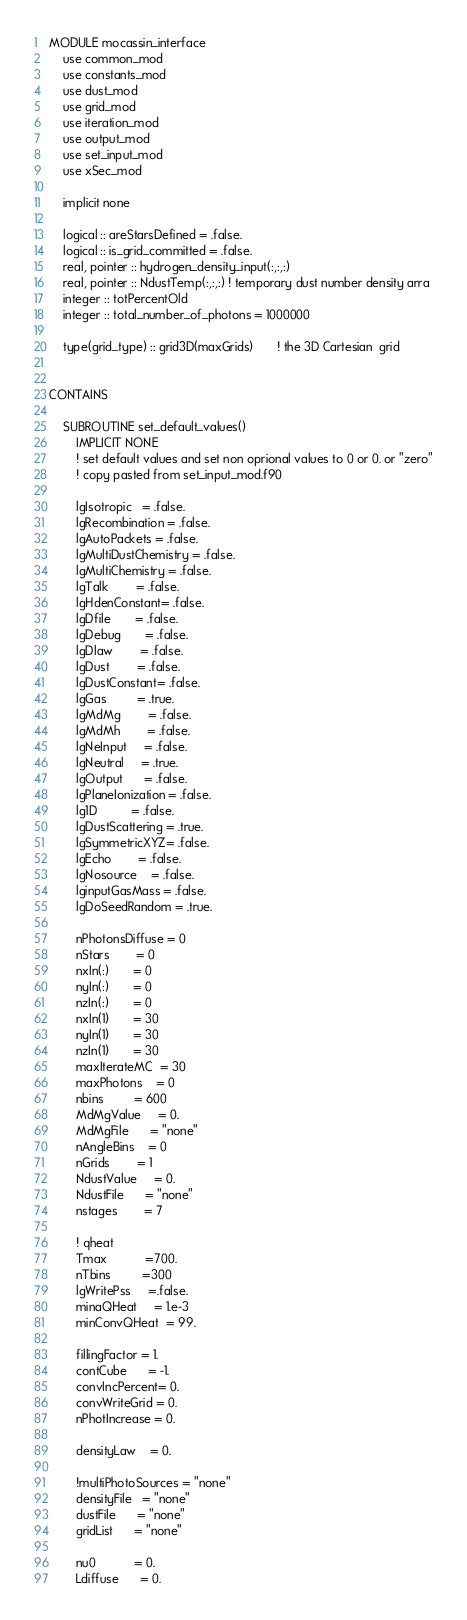Convert code to text. <code><loc_0><loc_0><loc_500><loc_500><_FORTRAN_>MODULE mocassin_interface
    use common_mod
    use constants_mod
    use dust_mod
    use grid_mod
    use iteration_mod
    use output_mod
    use set_input_mod
    use xSec_mod
    
    implicit none
    
    logical :: areStarsDefined = .false.
    logical :: is_grid_committed = .false.
    real, pointer :: hydrogen_density_input(:,:,:)
    real, pointer :: NdustTemp(:,:,:) ! temporary dust number density arra
    integer :: totPercentOld
    integer :: total_number_of_photons = 1000000
    
    type(grid_type) :: grid3D(maxGrids)       ! the 3D Cartesian  grid
    
    
CONTAINS

    SUBROUTINE set_default_values()
        IMPLICIT NONE
        ! set default values and set non oprional values to 0 or 0. or "zero"
        ! copy pasted from set_input_mod.f90

        lgIsotropic   = .false.       
        lgRecombination = .false.
        lgAutoPackets = .false.
        lgMultiDustChemistry = .false.
        lgMultiChemistry = .false.
        lgTalk        = .false.
        lgHdenConstant= .false.
        lgDfile       = .false.
        lgDebug       = .false.
        lgDlaw        = .false.
        lgDust        = .false.
        lgDustConstant= .false.
        lgGas         = .true.
        lgMdMg        = .false.
        lgMdMh        = .false.
        lgNeInput     = .false.
        lgNeutral     = .true.
        lgOutput      = .false. 
        lgPlaneIonization = .false.
        lg1D          = .false.
        lgDustScattering = .true.
        lgSymmetricXYZ= .false.
        lgEcho        = .false.
        lgNosource    = .false.
        lginputGasMass = .false.
        lgDoSeedRandom = .true.

        nPhotonsDiffuse = 0        
        nStars        = 0
        nxIn(:)       = 0
        nyIn(:)       = 0
        nzIn(:)       = 0
        nxIn(1)       = 30
        nyIn(1)       = 30
        nzIn(1)       = 30        
        maxIterateMC  = 30
        maxPhotons    = 0
        nbins         = 600        
        MdMgValue     = 0.
        MdMgFile      = "none"               
        nAngleBins    = 0        
        nGrids        = 1
        NdustValue     = 0.
        NdustFile      = "none"
        nstages        = 7
        
        ! qheat
        Tmax           =700.
        nTbins         =300
        lgWritePss     =.false.
        minaQHeat     = 1.e-3
        minConvQHeat  = 99.

        fillingFactor = 1.
        contCube      = -1.
        convIncPercent= 0.
        convWriteGrid = 0.
        nPhotIncrease = 0.

        densityLaw    = 0.

        !multiPhotoSources = "none"
        densityFile   = "none"
        dustFile      = "none"
        gridList      = "none"

        nu0           = 0.  
        Ldiffuse      = 0. </code> 